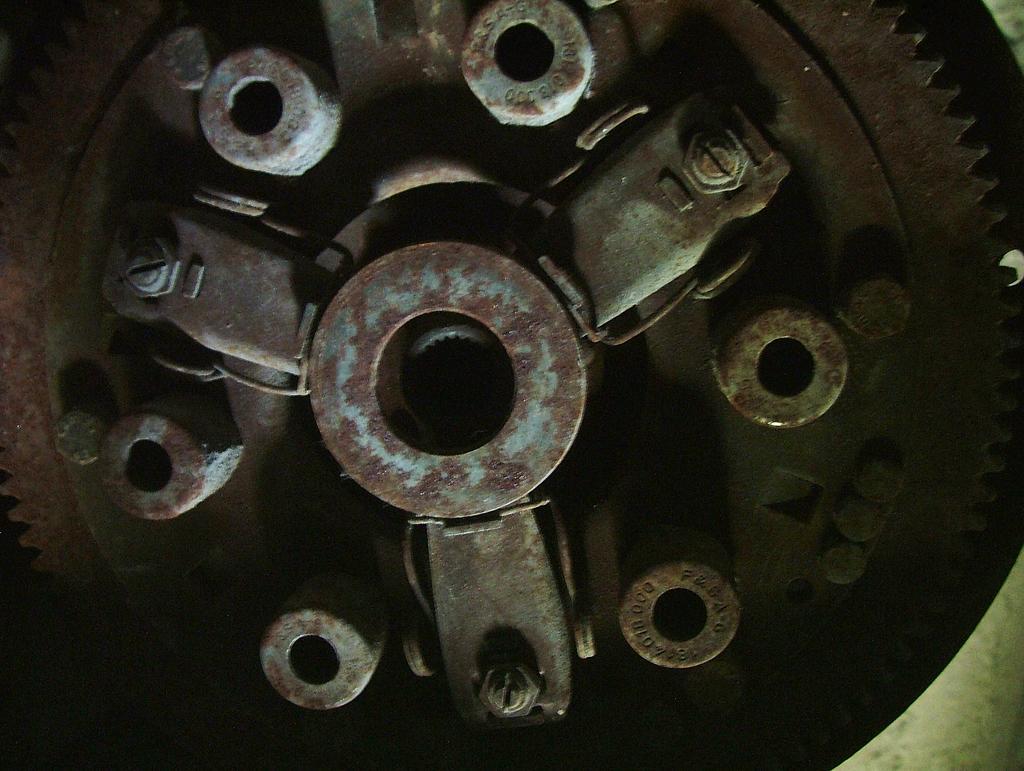In one or two sentences, can you explain what this image depicts? In this picture I can see a metal spike wheel. 